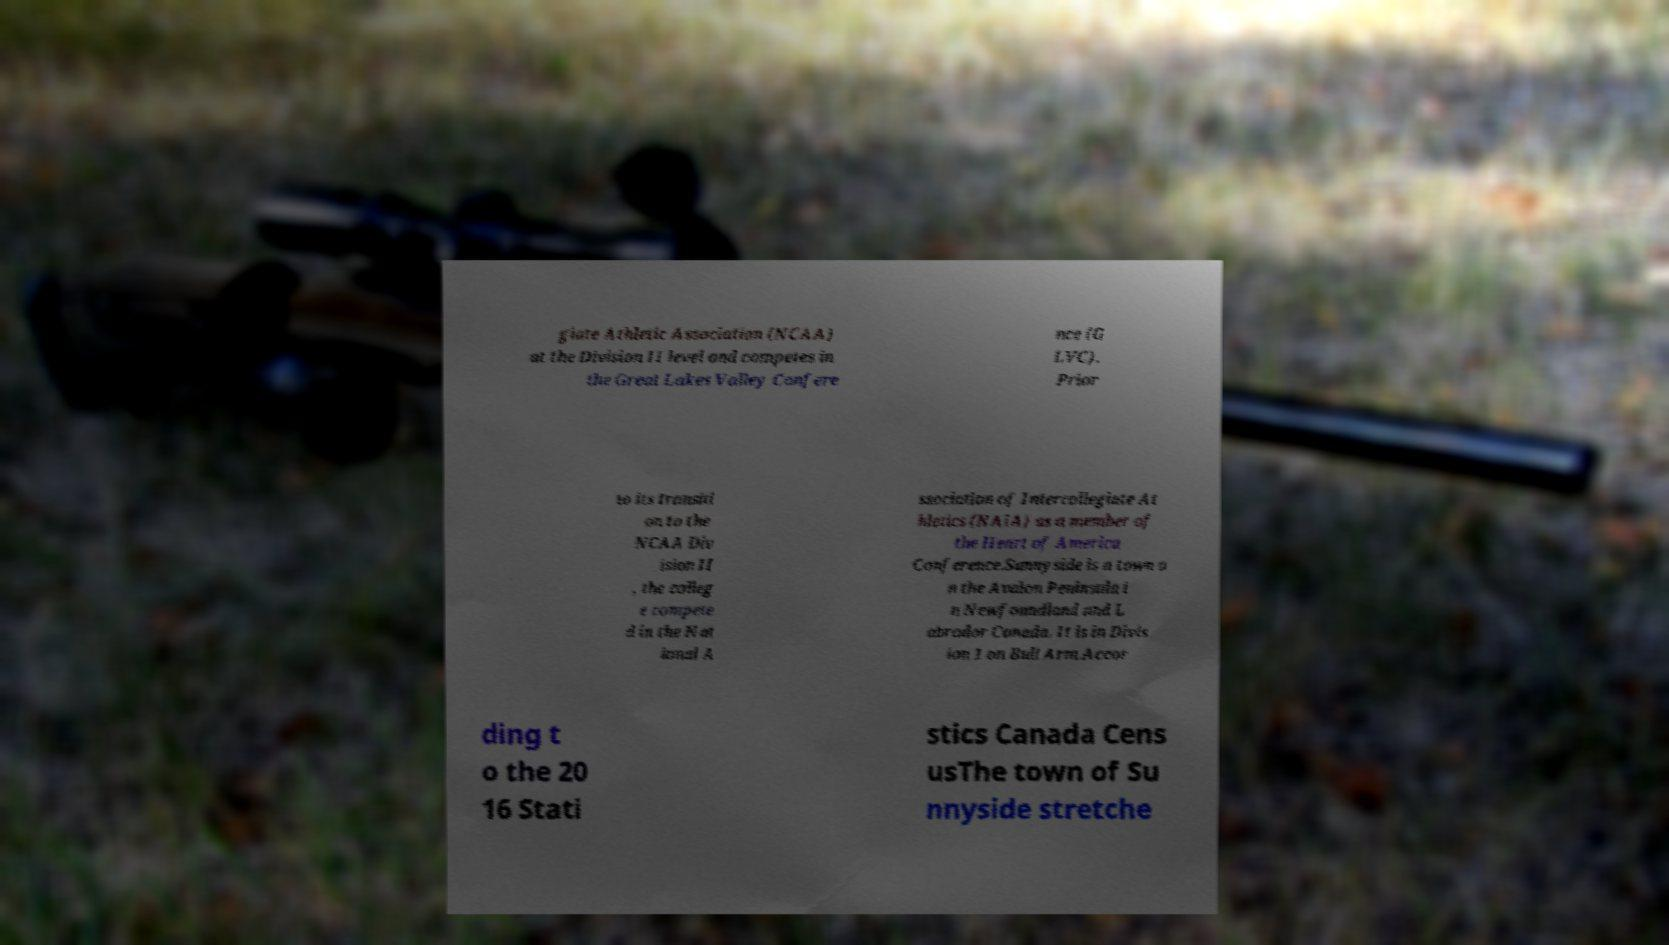Please read and relay the text visible in this image. What does it say? giate Athletic Association (NCAA) at the Division II level and competes in the Great Lakes Valley Confere nce (G LVC). Prior to its transiti on to the NCAA Div ision II , the colleg e compete d in the Nat ional A ssociation of Intercollegiate At hletics (NAIA) as a member of the Heart of America Conference.Sunnyside is a town o n the Avalon Peninsula i n Newfoundland and L abrador Canada. It is in Divis ion 1 on Bull Arm.Accor ding t o the 20 16 Stati stics Canada Cens usThe town of Su nnyside stretche 